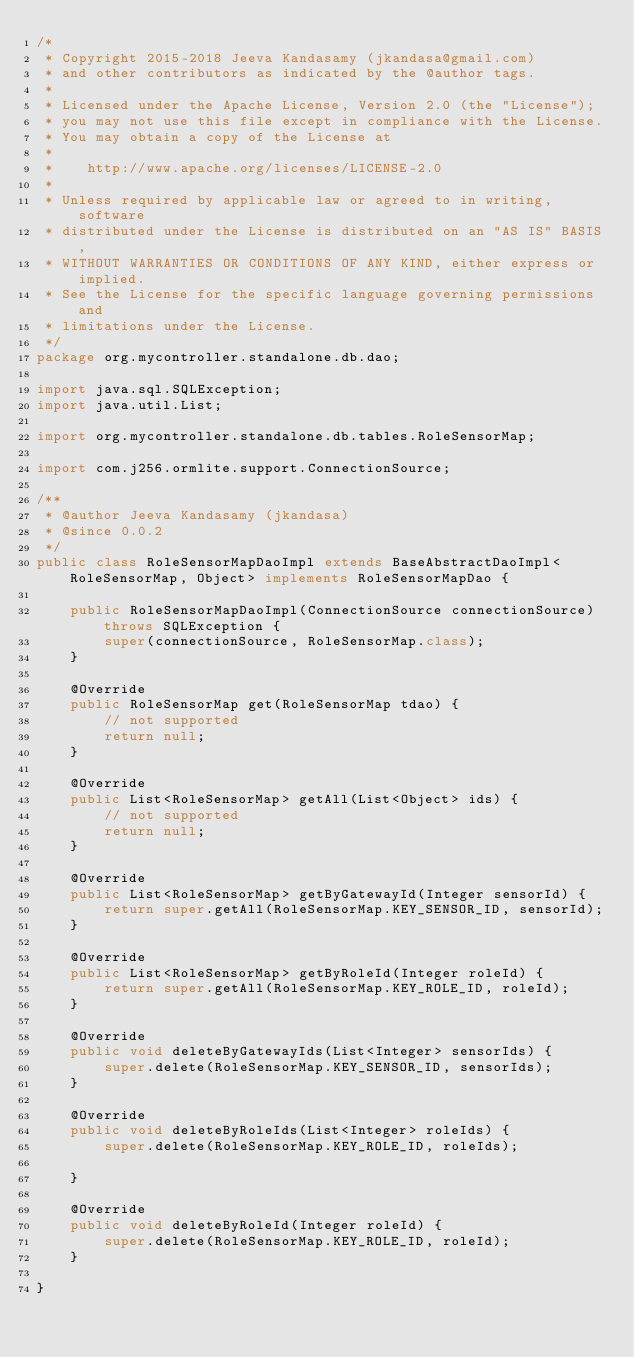<code> <loc_0><loc_0><loc_500><loc_500><_Java_>/*
 * Copyright 2015-2018 Jeeva Kandasamy (jkandasa@gmail.com)
 * and other contributors as indicated by the @author tags.
 *
 * Licensed under the Apache License, Version 2.0 (the "License");
 * you may not use this file except in compliance with the License.
 * You may obtain a copy of the License at
 *
 *    http://www.apache.org/licenses/LICENSE-2.0
 *
 * Unless required by applicable law or agreed to in writing, software
 * distributed under the License is distributed on an "AS IS" BASIS,
 * WITHOUT WARRANTIES OR CONDITIONS OF ANY KIND, either express or implied.
 * See the License for the specific language governing permissions and
 * limitations under the License.
 */
package org.mycontroller.standalone.db.dao;

import java.sql.SQLException;
import java.util.List;

import org.mycontroller.standalone.db.tables.RoleSensorMap;

import com.j256.ormlite.support.ConnectionSource;

/**
 * @author Jeeva Kandasamy (jkandasa)
 * @since 0.0.2
 */
public class RoleSensorMapDaoImpl extends BaseAbstractDaoImpl<RoleSensorMap, Object> implements RoleSensorMapDao {

    public RoleSensorMapDaoImpl(ConnectionSource connectionSource) throws SQLException {
        super(connectionSource, RoleSensorMap.class);
    }

    @Override
    public RoleSensorMap get(RoleSensorMap tdao) {
        // not supported
        return null;
    }

    @Override
    public List<RoleSensorMap> getAll(List<Object> ids) {
        // not supported
        return null;
    }

    @Override
    public List<RoleSensorMap> getByGatewayId(Integer sensorId) {
        return super.getAll(RoleSensorMap.KEY_SENSOR_ID, sensorId);
    }

    @Override
    public List<RoleSensorMap> getByRoleId(Integer roleId) {
        return super.getAll(RoleSensorMap.KEY_ROLE_ID, roleId);
    }

    @Override
    public void deleteByGatewayIds(List<Integer> sensorIds) {
        super.delete(RoleSensorMap.KEY_SENSOR_ID, sensorIds);
    }

    @Override
    public void deleteByRoleIds(List<Integer> roleIds) {
        super.delete(RoleSensorMap.KEY_ROLE_ID, roleIds);

    }

    @Override
    public void deleteByRoleId(Integer roleId) {
        super.delete(RoleSensorMap.KEY_ROLE_ID, roleId);
    }

}
</code> 